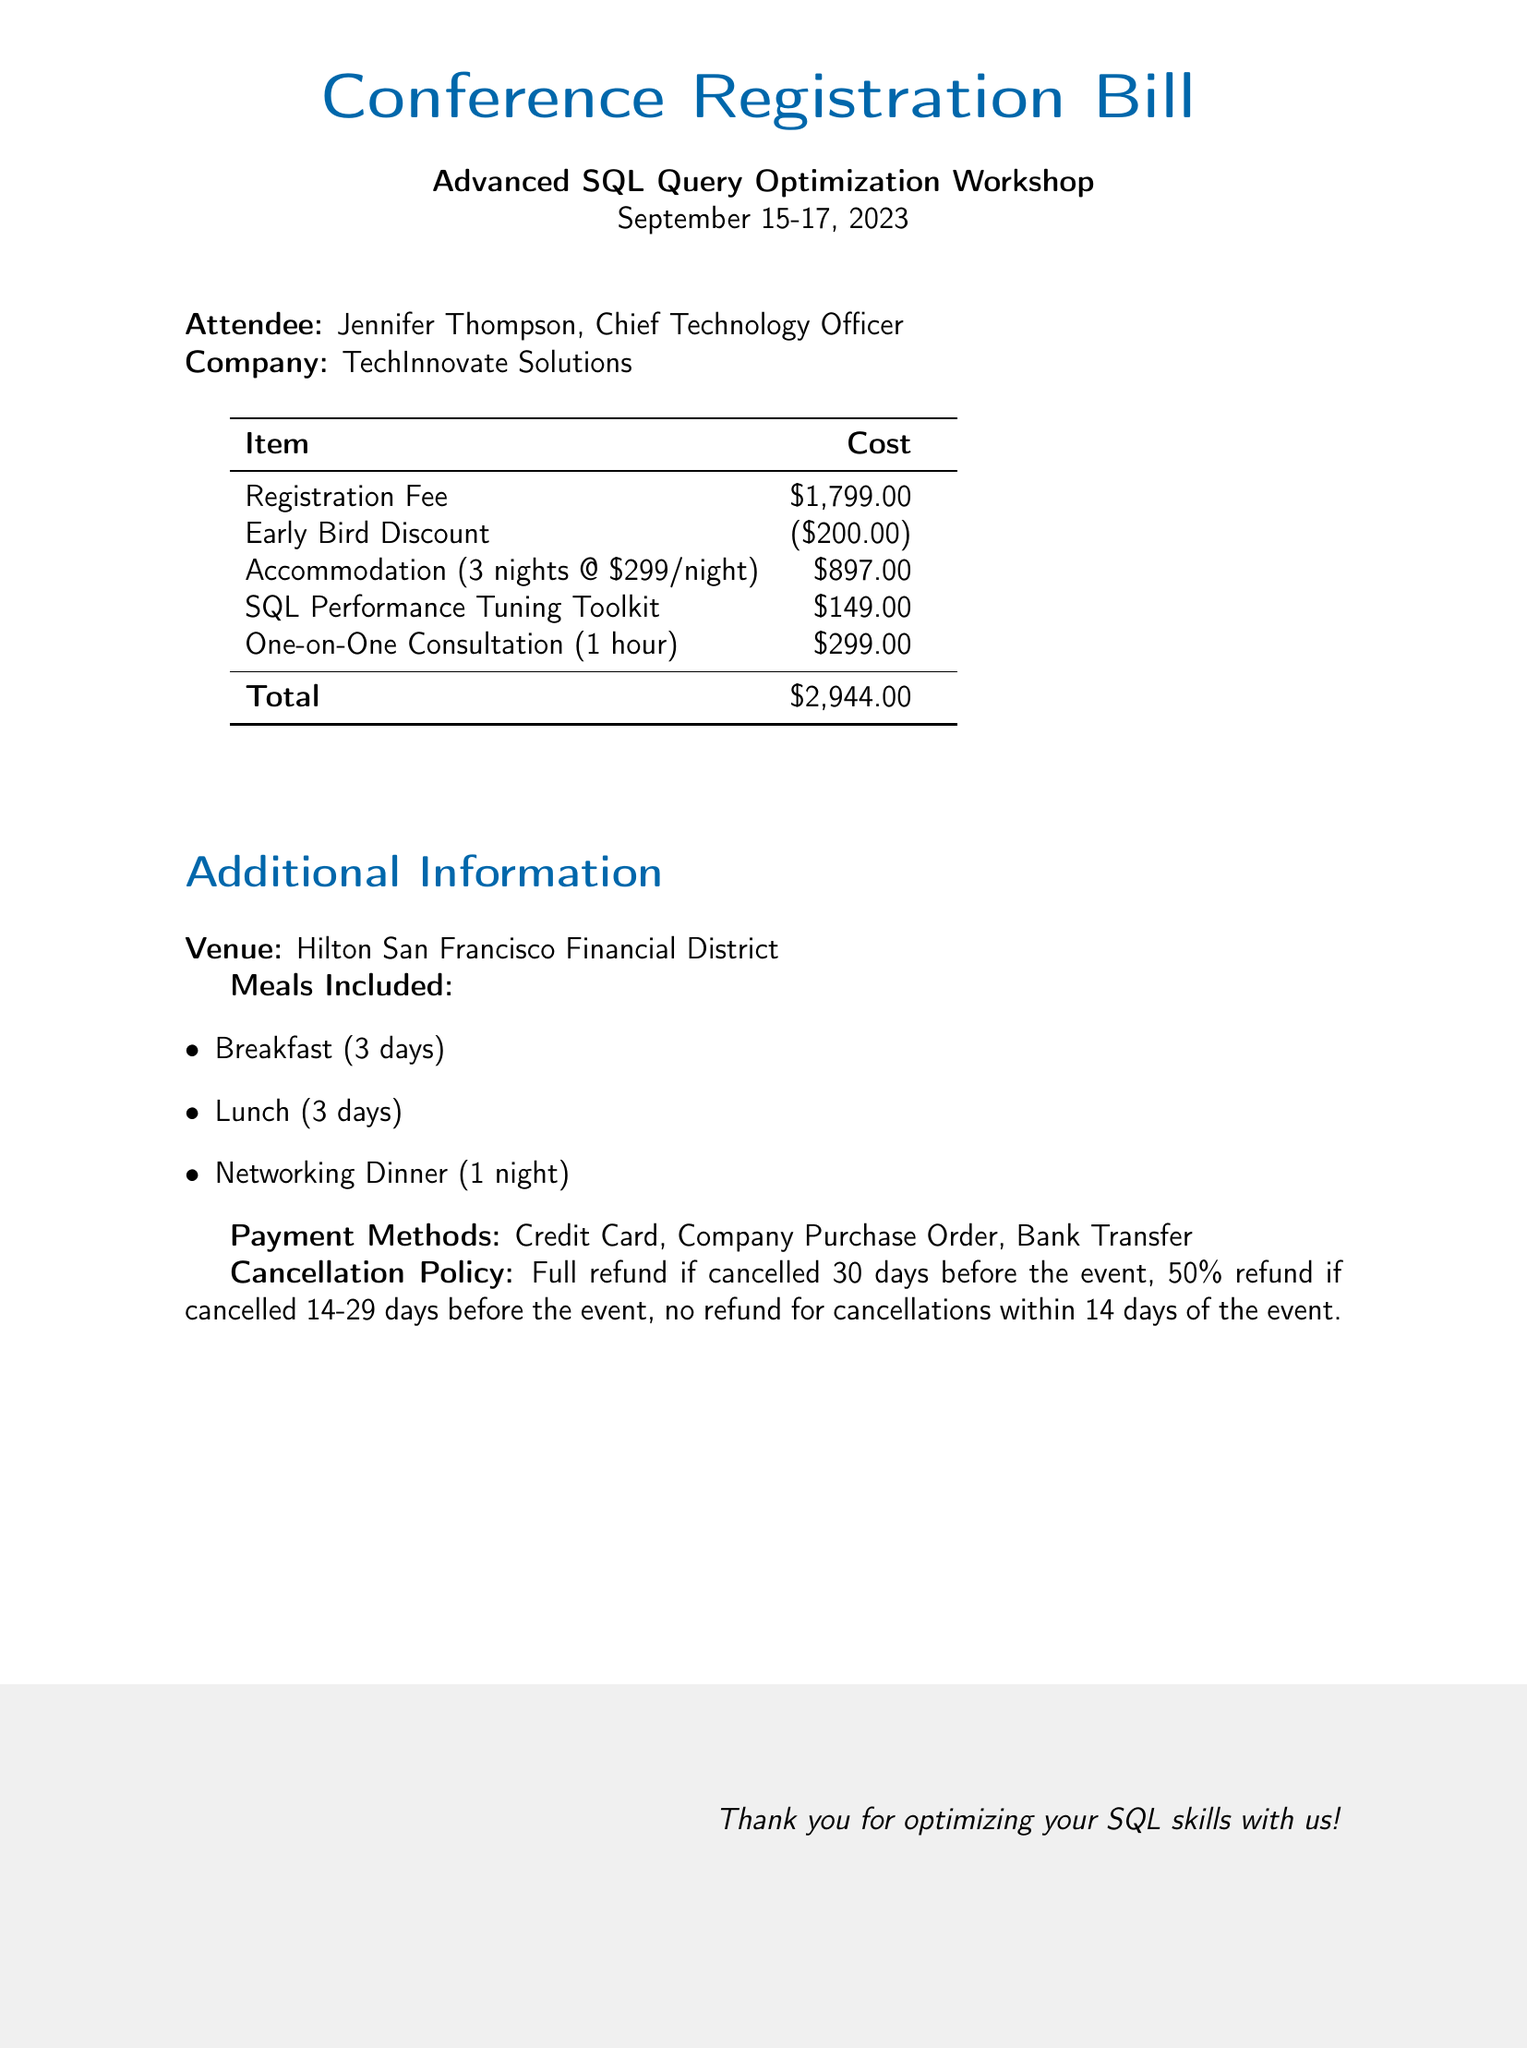What is the name of the workshop? The workshop is titled "Advanced SQL Query Optimization Workshop."
Answer: Advanced SQL Query Optimization Workshop What is the registration fee? The document states the registration fee as $1,799.00.
Answer: $1,799.00 How much is the early bird discount? The early bird discount amount mentioned is $200.00.
Answer: $200.00 What is the total cost? The total cost, which is calculated after all fees and discounts, is $2,944.00.
Answer: $2,944.00 What is included in the accommodation cost? The accommodation cost is calculated for 3 nights at $299 each night.
Answer: 3 nights @ $299/night Who is the attendee? The document specifies the attendee as Jennifer Thompson.
Answer: Jennifer Thompson What meals are included in the workshop? The included meals are breakfast, lunch, and a networking dinner.
Answer: Breakfast, Lunch, Networking Dinner What payment methods are accepted? The document lists credit card, company purchase order, and bank transfer as payment methods.
Answer: Credit Card, Company Purchase Order, Bank Transfer What is the cancellation policy for this event? The cancellation policy outlines a full refund if canceled 30 days before, 50% if 14-29 days prior, and no refund within 14 days.
Answer: Full refund if cancelled 30 days before the event, 50% refund if cancelled 14-29 days before the event, no refund for cancellations within 14 days 